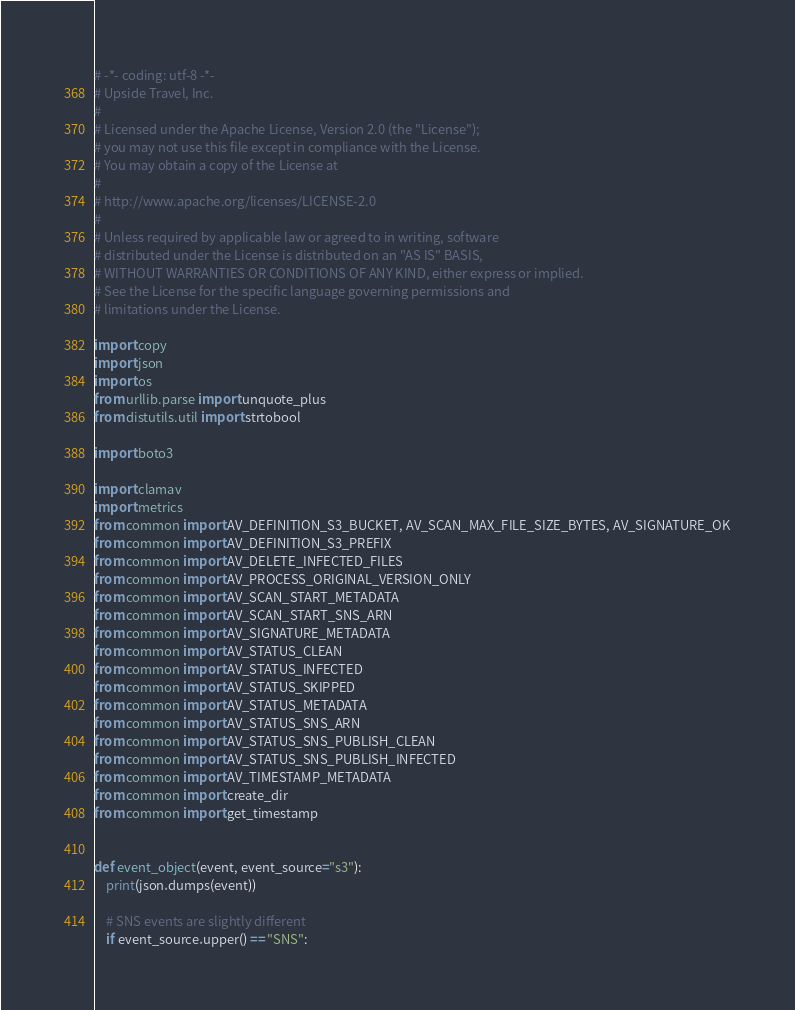<code> <loc_0><loc_0><loc_500><loc_500><_Python_># -*- coding: utf-8 -*-
# Upside Travel, Inc.
#
# Licensed under the Apache License, Version 2.0 (the "License");
# you may not use this file except in compliance with the License.
# You may obtain a copy of the License at
#
# http://www.apache.org/licenses/LICENSE-2.0
#
# Unless required by applicable law or agreed to in writing, software
# distributed under the License is distributed on an "AS IS" BASIS,
# WITHOUT WARRANTIES OR CONDITIONS OF ANY KIND, either express or implied.
# See the License for the specific language governing permissions and
# limitations under the License.

import copy
import json
import os
from urllib.parse import unquote_plus
from distutils.util import strtobool

import boto3

import clamav
import metrics
from common import AV_DEFINITION_S3_BUCKET, AV_SCAN_MAX_FILE_SIZE_BYTES, AV_SIGNATURE_OK
from common import AV_DEFINITION_S3_PREFIX
from common import AV_DELETE_INFECTED_FILES
from common import AV_PROCESS_ORIGINAL_VERSION_ONLY
from common import AV_SCAN_START_METADATA
from common import AV_SCAN_START_SNS_ARN
from common import AV_SIGNATURE_METADATA
from common import AV_STATUS_CLEAN
from common import AV_STATUS_INFECTED
from common import AV_STATUS_SKIPPED
from common import AV_STATUS_METADATA
from common import AV_STATUS_SNS_ARN
from common import AV_STATUS_SNS_PUBLISH_CLEAN
from common import AV_STATUS_SNS_PUBLISH_INFECTED
from common import AV_TIMESTAMP_METADATA
from common import create_dir
from common import get_timestamp


def event_object(event, event_source="s3"):
    print(json.dumps(event))

    # SNS events are slightly different
    if event_source.upper() == "SNS":</code> 